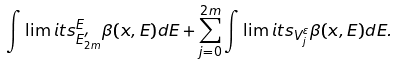<formula> <loc_0><loc_0><loc_500><loc_500>\int \lim i t s _ { E _ { 2 m } ^ { \prime } } ^ { E } \beta ( x , E ) d E + \sum _ { j = 0 } ^ { 2 m } \int \lim i t s _ { V _ { j } ^ { \varepsilon } } \beta ( x , E ) d E .</formula> 